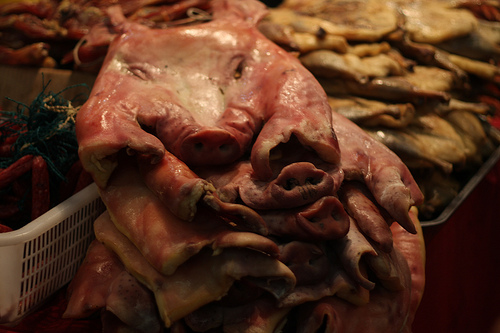<image>
Is the pig meat in the tray? No. The pig meat is not contained within the tray. These objects have a different spatial relationship. 